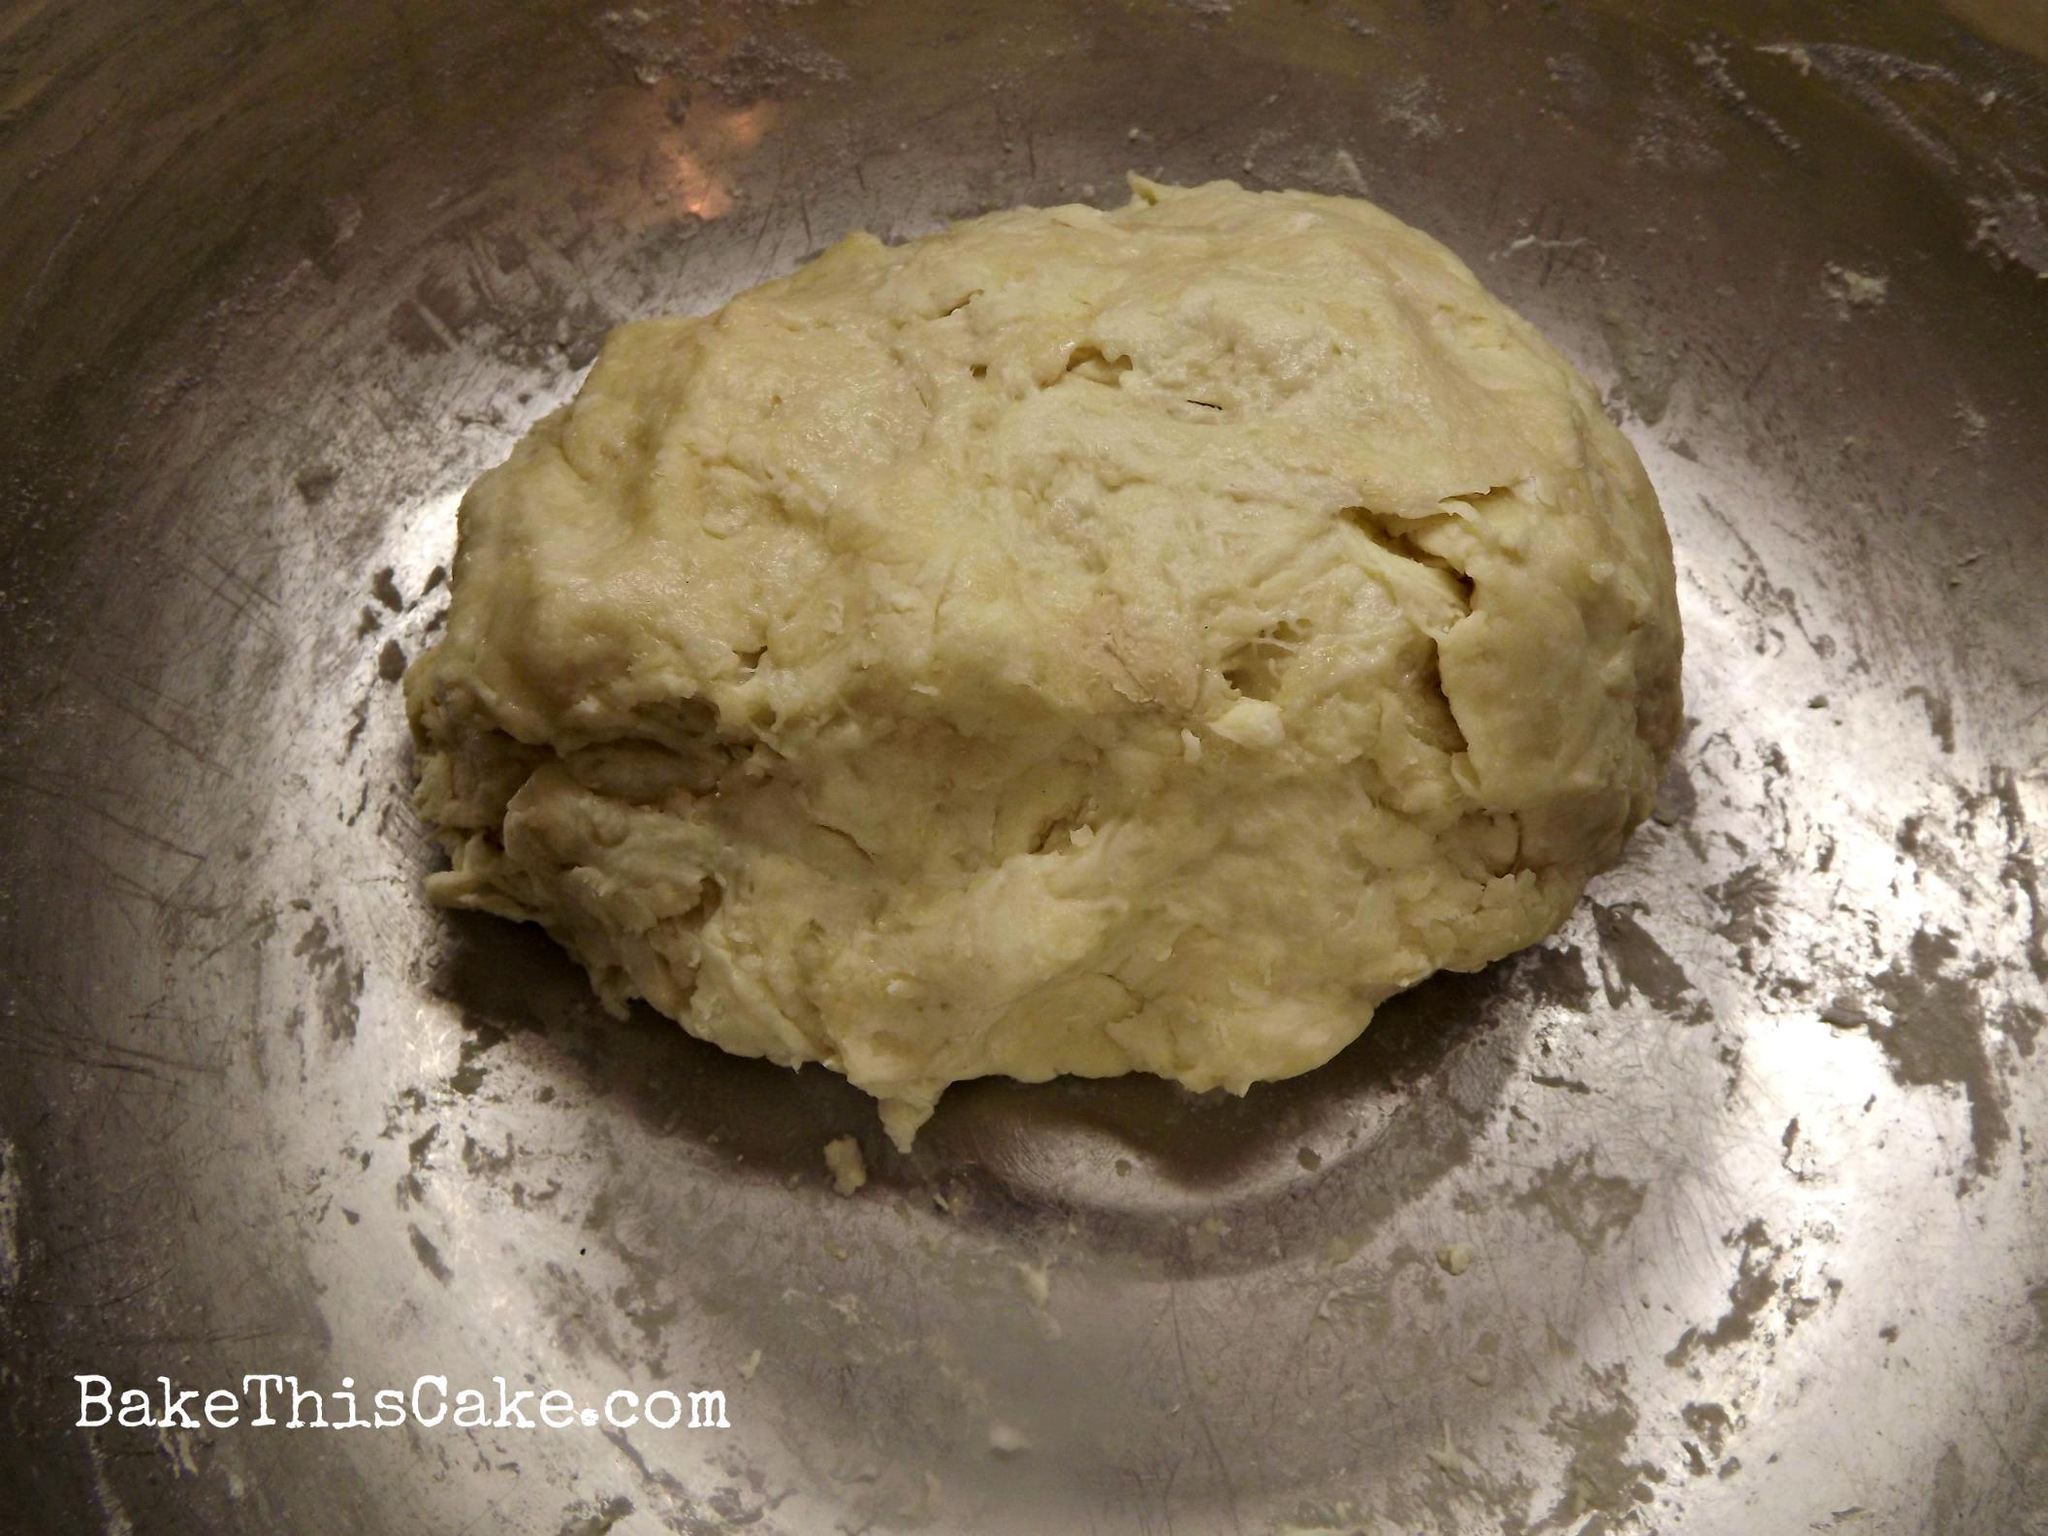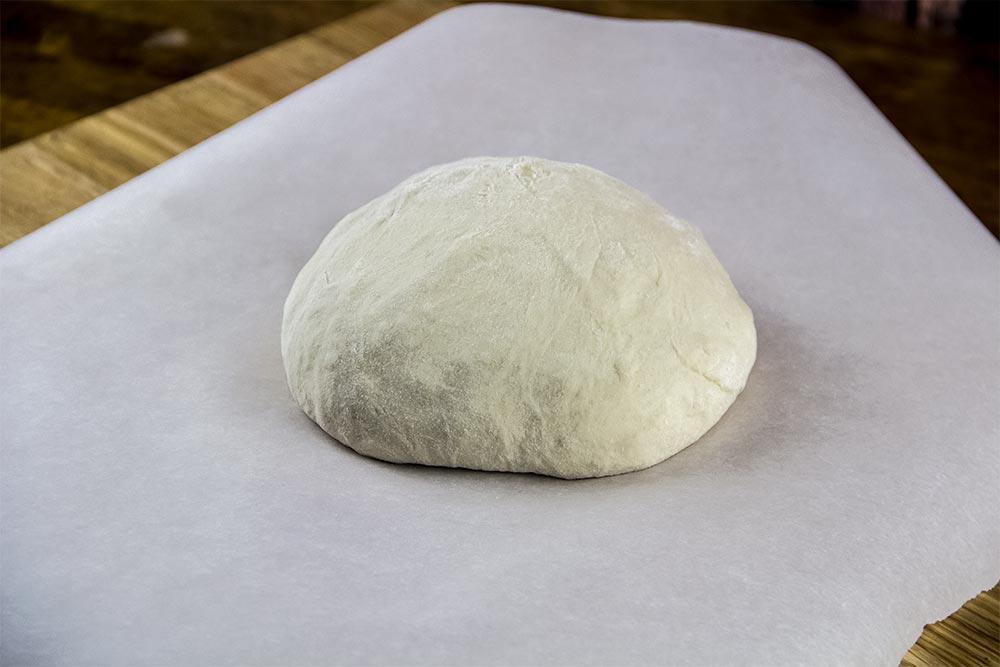The first image is the image on the left, the second image is the image on the right. For the images displayed, is the sentence "The left and right image contains the same number of balls of dough." factually correct? Answer yes or no. Yes. The first image is the image on the left, the second image is the image on the right. For the images shown, is this caption "Each image contains one rounded ball of raw dough." true? Answer yes or no. Yes. 